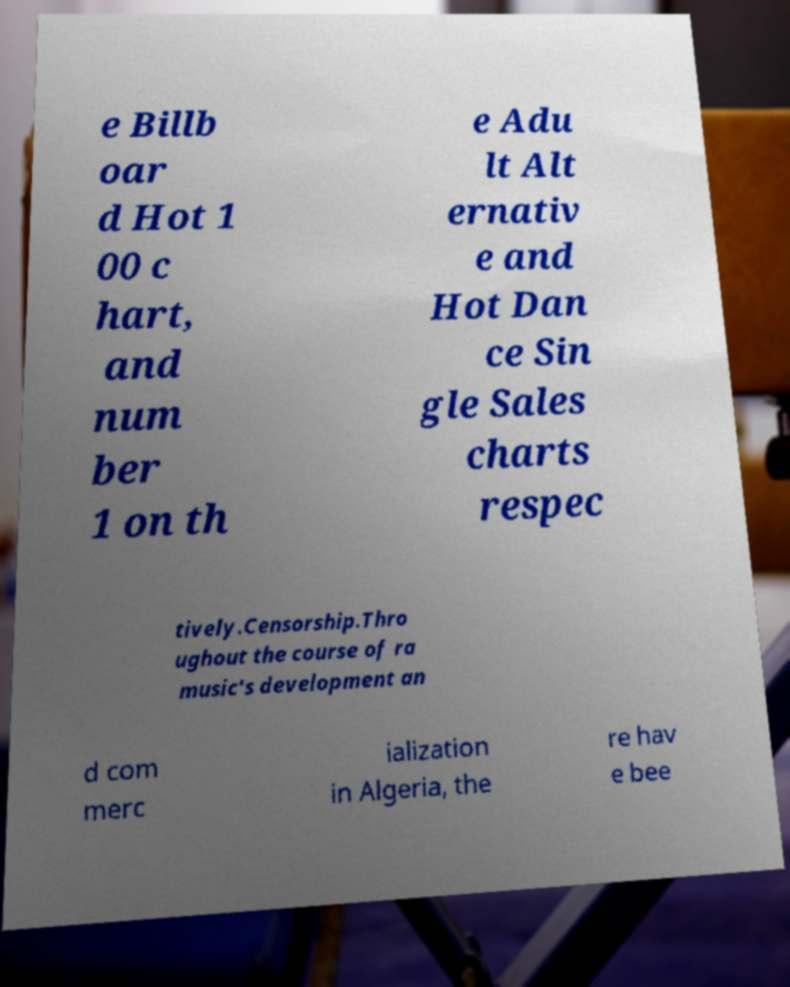Could you assist in decoding the text presented in this image and type it out clearly? e Billb oar d Hot 1 00 c hart, and num ber 1 on th e Adu lt Alt ernativ e and Hot Dan ce Sin gle Sales charts respec tively.Censorship.Thro ughout the course of ra music's development an d com merc ialization in Algeria, the re hav e bee 